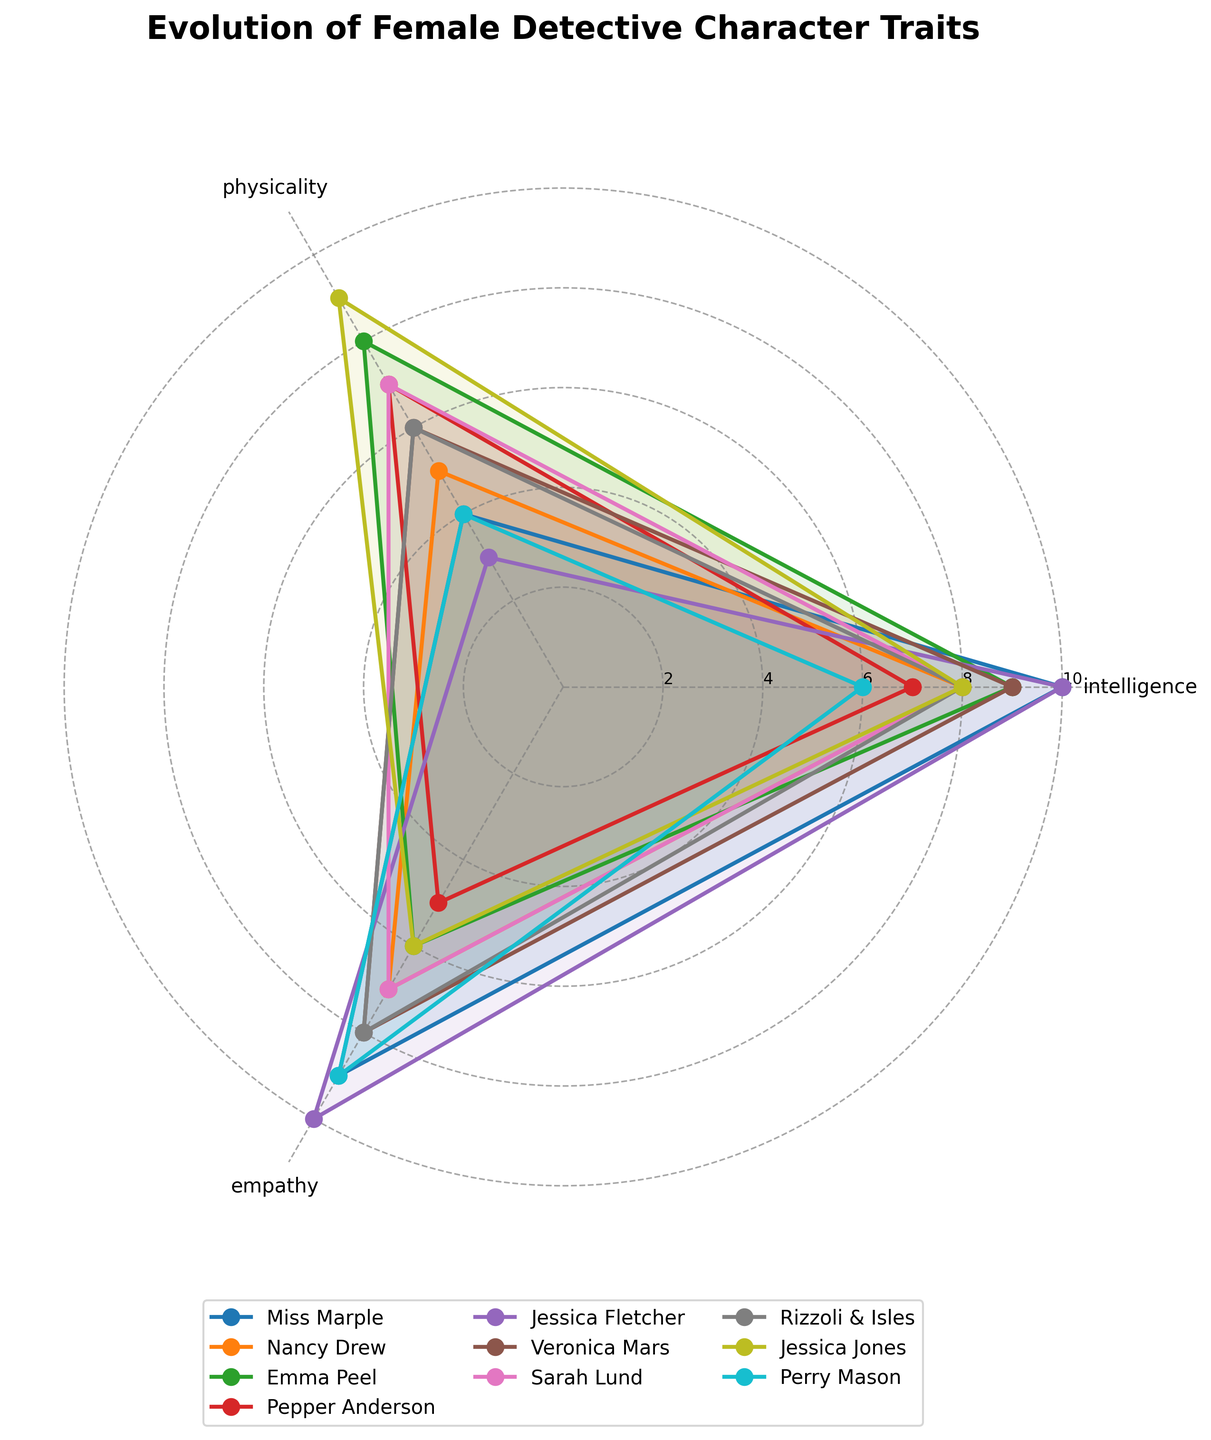What is the title of the polar scatter chart? The title is usually displayed at the top of the chart. In this chart, the title is "Evolution of Female Detective Character Traits".
Answer: Evolution of Female Detective Character Traits How many character names are present in the legend? The legend, typically located below the chart, lists the character names that are plotted. By counting these names, you can see there are 10 character names.
Answer: 10 Which character appears to have the highest physicality? By examining the plot, we can identify the character with the highest value on the physicality axis. The character with the trait point farthest on the physicality dimension (which appears around the '2 o'clock' position) is Jessica Jones.
Answer: Jessica Jones What traits are used on the polar chart? Looking at the labels on the axes, we can spot three terms corresponding to the plotted traits. These are 'intelligence', 'physicality', and 'empathy'.
Answer: Intelligence, Physicality, Empathy Which character exhibits the highest empathy in the 1980s? By locating the plot line for the 1980s decade and seeing where it extends the farthest around the empathy axis, we see that Jessica Fletcher has the highest empathy score in this time period.
Answer: Jessica Fletcher Compare the intelligence scores of Miss Marple and Nancy Drew. Which one is higher? Observing the intelligence axis and comparing the positions of Miss Marple’s and Nancy Drew's lines, it's clear that Miss Marple has a higher intelligence score than Nancy Drew.
Answer: Miss Marple Which decade features the character with the lowest physicality score? By identifying the character with the lowest physicality value and seeing their decade, we observe that Jessica Fletcher in the 1980s has the lowest physicality score.
Answer: 1980s How does the empathy score of Veronica Mars compare to Sarah Lund? Adding a comparison of values for both characters on the empathy axis reveals that Veronica Mars has a higher empathy score (8) than Sarah Lund (7).
Answer: Veronica Mars Sum the intelligence and physicality scores for Emma Peel. By adding Emma Peel’s scores for intelligence (9) and physicality (8), we get a total of 17.
Answer: 17 Which character has nearly equal intelligence and empathy scores? Checking the plot lines where the points for intelligence and empathy nearly meet together, we find that Perry Mason has almost equal scores of intelligence (6) and empathy (9).
Answer: Perry Mason 